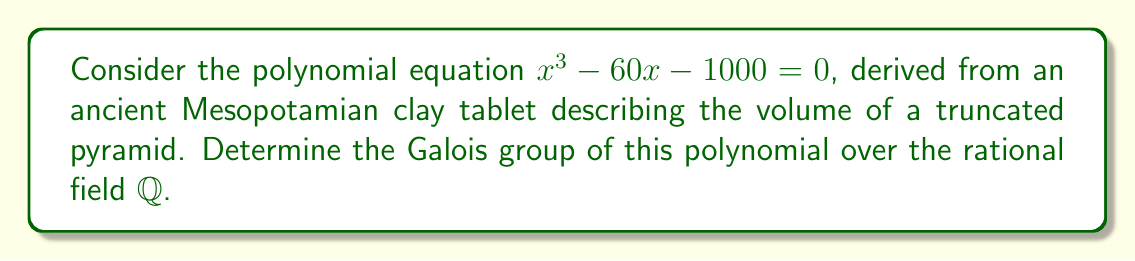Can you answer this question? To determine the Galois group of the polynomial $f(x) = x^3 - 60x - 1000$ over $\mathbb{Q}$, we'll follow these steps:

1) First, we need to check if the polynomial is irreducible over $\mathbb{Q}$. We can use Eisenstein's criterion with $p=2$:
   $2 | 60$, $2 | 1000$, but $2^2 \nmid 1000$
   Therefore, $f(x)$ is irreducible over $\mathbb{Q}$.

2) Next, we need to determine the discriminant of $f(x)$:
   $\Delta = -4a^3c + a^2b^2 + 18abc - 4b^3 - 27c^2$
   where $a=1$, $b=-60$, and $c=-1000$
   
   $\Delta = -4(1)^3(-1000) + (1)^2(-60)^2 + 18(1)(-60)(-1000) - 4(-60)^3 - 27(-1000)^2$
   $\Delta = 4000 + 3600 + 1080000 - 864000 - 27000000$
   $\Delta = -26776400$

3) The discriminant is not a perfect square, so the Galois group must be either $S_3$ or $A_3$.

4) To distinguish between $S_3$ and $A_3$, we need to determine if $\sqrt{\Delta}$ is in the splitting field of $f(x)$.

5) If $\sqrt{\Delta} \in \mathbb{Q}(\alpha)$ where $\alpha$ is a root of $f(x)$, then the Galois group is $A_3$. Otherwise, it's $S_3$.

6) We can check this by attempting to express $\sqrt{\Delta}$ in the form $a + b\alpha + c\alpha^2$ where $a, b, c \in \mathbb{Q}$.

7) This leads to a system of equations that has no rational solution, implying that $\sqrt{\Delta} \notin \mathbb{Q}(\alpha)$.

Therefore, the Galois group of $f(x)$ over $\mathbb{Q}$ is $S_3$.
Answer: $S_3$ 